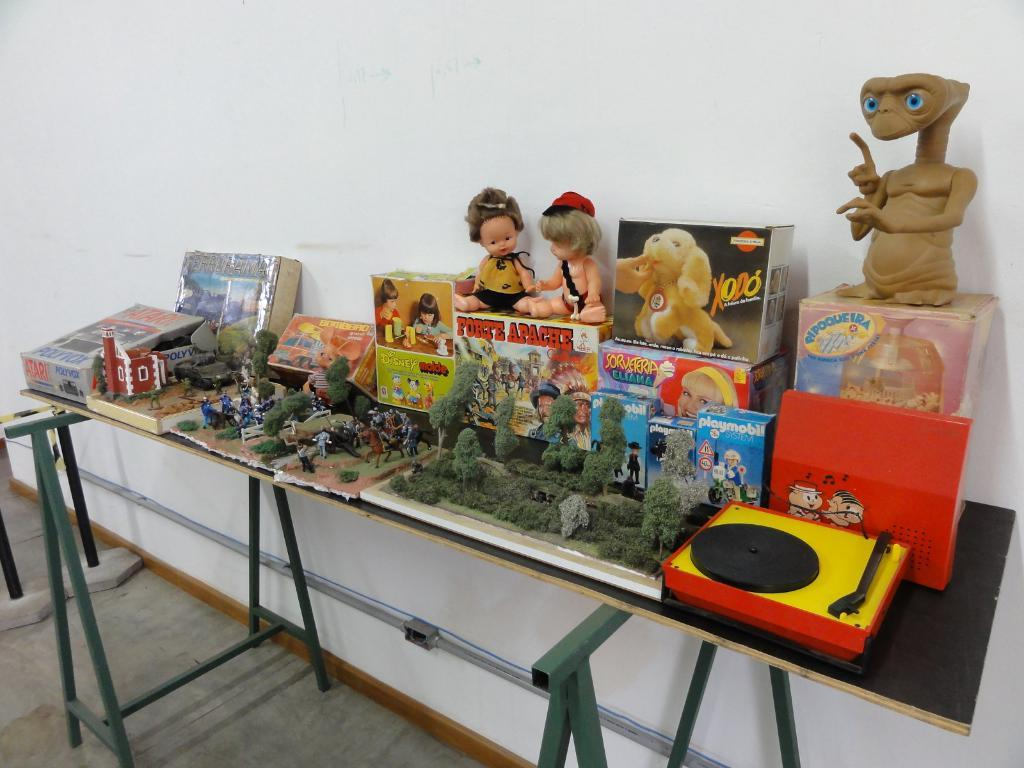<image>
Present a compact description of the photo's key features. Two sawhorse's have a sheet of wood between them, acting as a table, with antique toys such as an ET figure and an Atari displayed on it. 